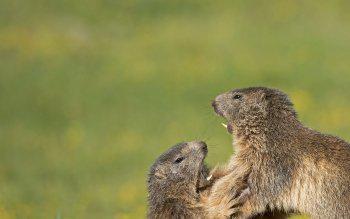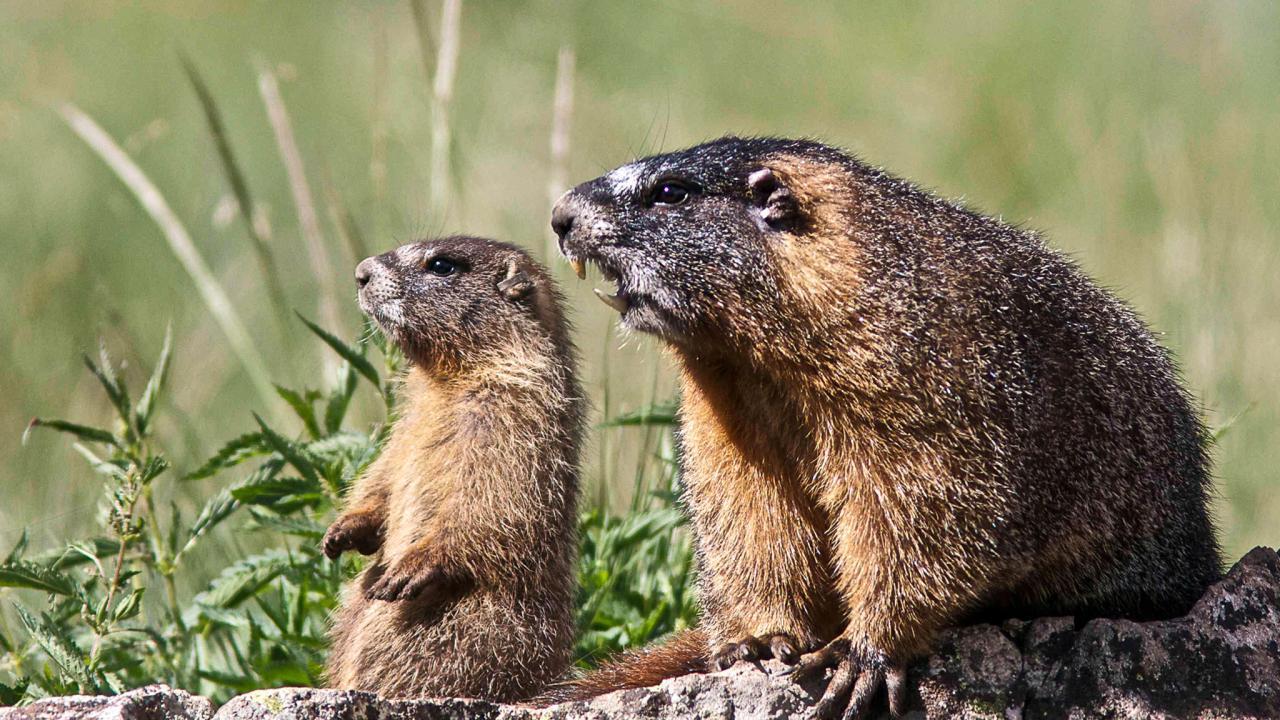The first image is the image on the left, the second image is the image on the right. Analyze the images presented: Is the assertion "There are more than two animals total." valid? Answer yes or no. Yes. 